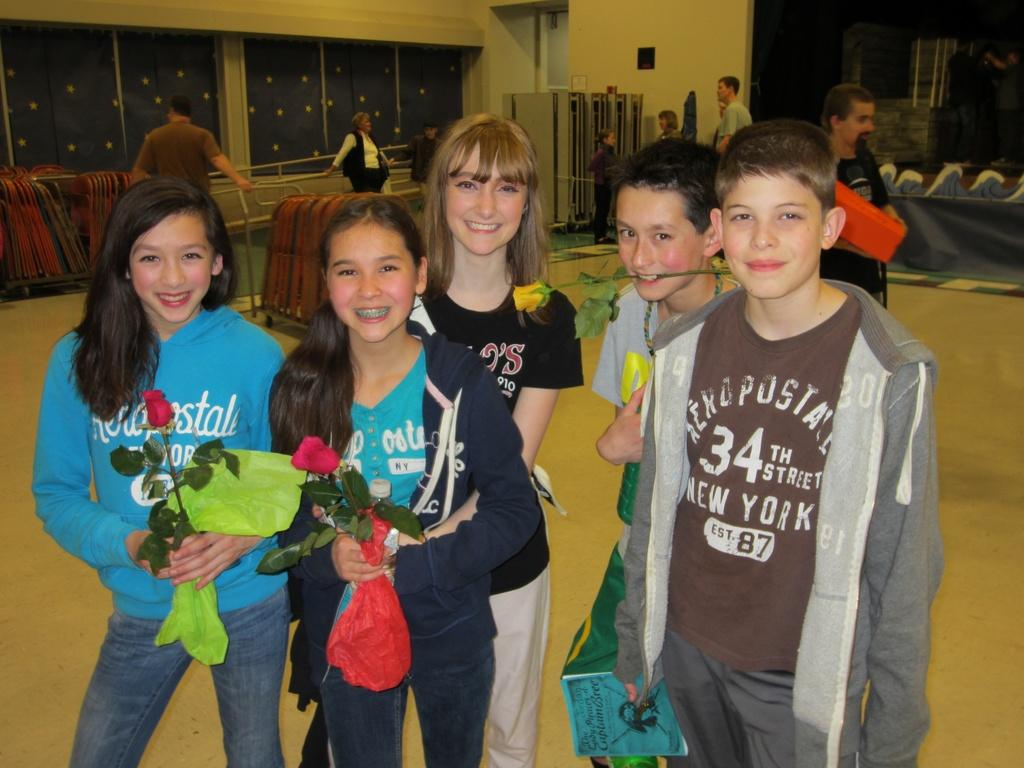What are the persons in the image holding? The persons in the image are holding flowers. Where are the persons standing in the image? The persons are standing on the ground. Can you describe the background of the image? In the background of the image, there are persons, chairs, windows, a switch board, a door, and a wall. How many persons can be seen in the image? There are persons in the foreground and background, so the total number of persons cannot be determined from the provided facts. What type of structure is visible in the background of the image? A wall is visible in the background of the image. What type of magic is being performed by the persons with flowers in the image? There is no indication of magic or any magical activity in the image. Can you tell me how many hoses are visible in the image? There are no hoses present in the image. 